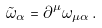<formula> <loc_0><loc_0><loc_500><loc_500>\tilde { \omega } _ { \alpha } & = \partial ^ { \mu } \omega _ { \mu \alpha } \, .</formula> 